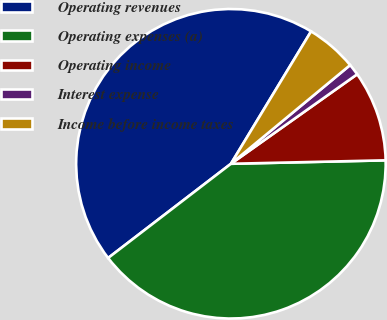<chart> <loc_0><loc_0><loc_500><loc_500><pie_chart><fcel>Operating revenues<fcel>Operating expenses (a)<fcel>Operating income<fcel>Interest expense<fcel>Income before income taxes<nl><fcel>44.08%<fcel>39.94%<fcel>9.46%<fcel>1.19%<fcel>5.33%<nl></chart> 